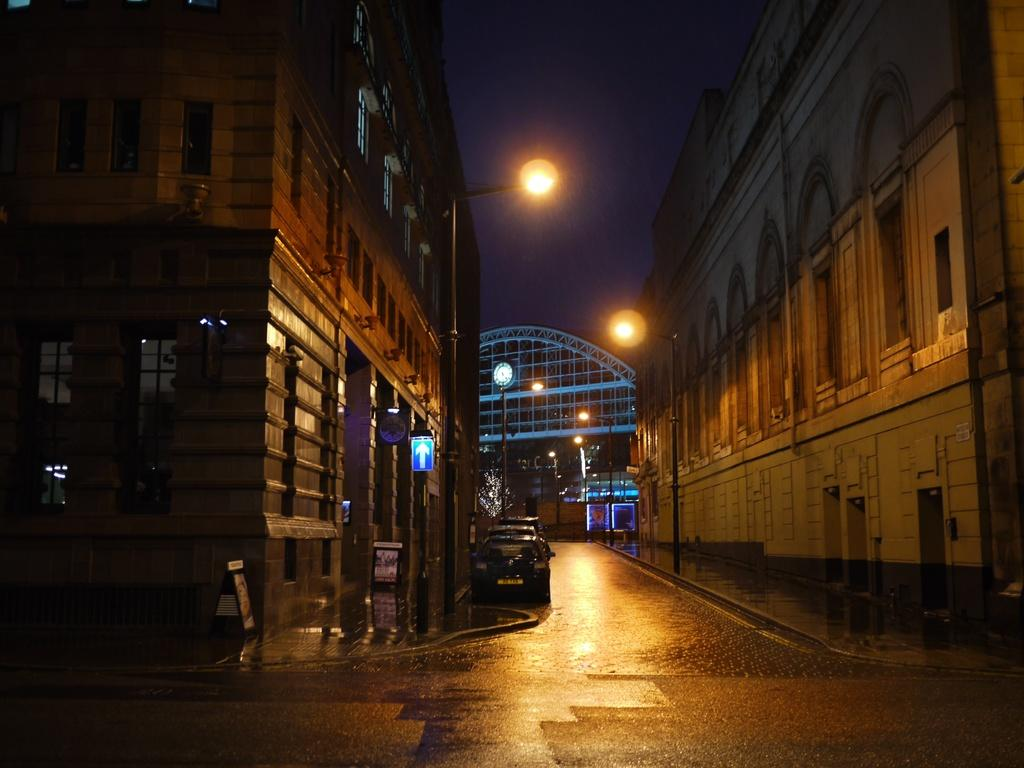What type of structures can be seen in the image? There are buildings in the image. What else can be seen moving in the image? There are vehicles in the image. What type of lighting is present in the image? There are street lamps in the image. What time-related object is visible in the image? There is a clock in the image. What natural element is visible in the image? There is water visible in the image. What part of the sky is visible in the image? The sky is visible in the image. How would you describe the lighting conditions in the image? The image is described as being a little dark. How many minutes are visible on the clock in the image? There is no indication of the specific time on the clock in the image, so the number of minutes cannot be determined. What type of cemetery can be seen in the image? There is no cemetery present in the image. What is the sack used for in the image? There is no sack present in the image. 